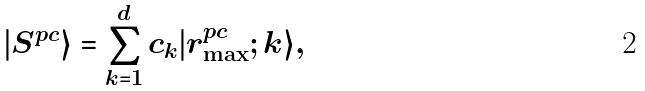<formula> <loc_0><loc_0><loc_500><loc_500>| S ^ { p c } \rangle = \sum _ { k = 1 } ^ { d } c _ { k } | r _ { \max } ^ { p c } ; k \rangle ,</formula> 